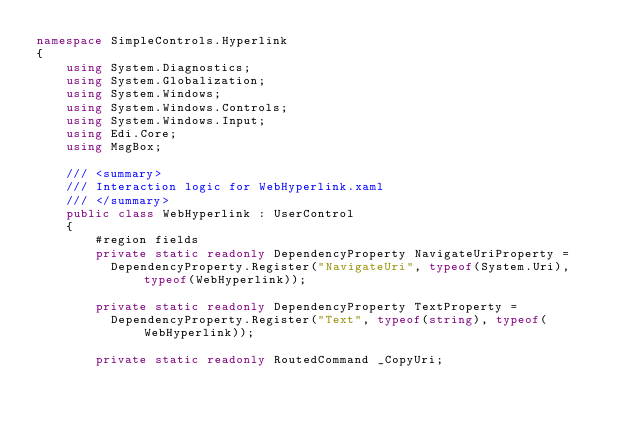Convert code to text. <code><loc_0><loc_0><loc_500><loc_500><_C#_>namespace SimpleControls.Hyperlink
{
    using System.Diagnostics;
    using System.Globalization;
    using System.Windows;
    using System.Windows.Controls;
    using System.Windows.Input;
    using Edi.Core;
    using MsgBox;

    /// <summary>
    /// Interaction logic for WebHyperlink.xaml
    /// </summary>
    public class WebHyperlink : UserControl
    {
        #region fields
        private static readonly DependencyProperty NavigateUriProperty =
          DependencyProperty.Register("NavigateUri", typeof(System.Uri), typeof(WebHyperlink));

        private static readonly DependencyProperty TextProperty =
          DependencyProperty.Register("Text", typeof(string), typeof(WebHyperlink));

        private static readonly RoutedCommand _CopyUri;</code> 